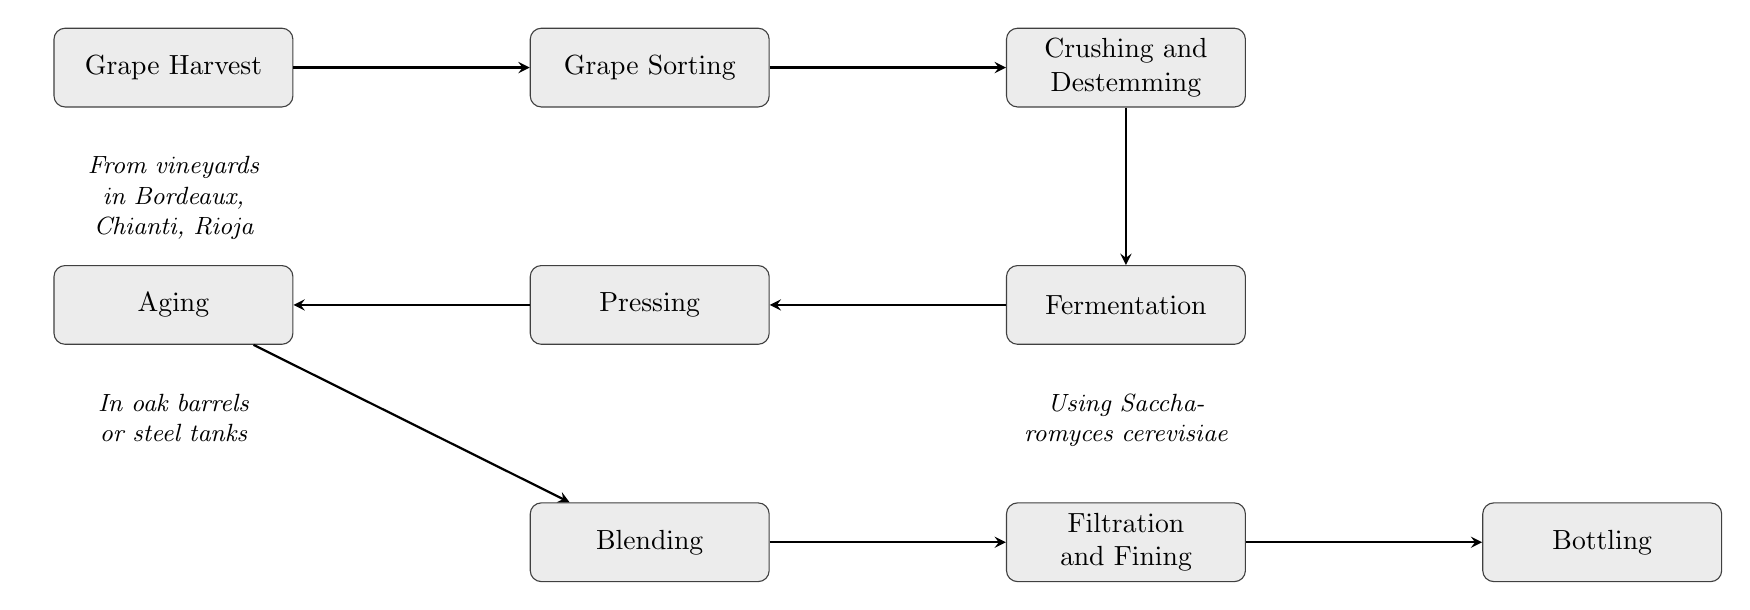What is the first step in the journey of red wine? The first node in the diagram is "Grape Harvest", indicating that the process begins with this step.
Answer: Grape Harvest How many nodes are in the diagram? By counting the distinct processes listed in the diagram, there are a total of nine nodes.
Answer: 9 What follows after Grape Sorting? The diagram shows an arrow leading from "Grape Sorting" to "Crushing and Destemming", indicating that this is the next step in the process.
Answer: Crushing and Destemming Which process involves aging in barrels? The node labeled "Aging" describes the process of aging wine in oak barrels or stainless-steel tanks.
Answer: Aging What is used during the fermentation process? The annotation under the "Fermentation" node indicates that Saccharomyces cerevisiae is commonly used as yeast during this stage.
Answer: Saccharomyces cerevisiae What is the relationship between Pressing and Pressing? The diagram shows that after "Fermentation", the flow goes to "Pressing", indicating a sequential relationship where pressing occurs after fermentation.
Answer: Sequential relationship Which step immediately precedes Bottling? According to the flow chart, the step "Filtration and Fining" comes right before "Bottling".
Answer: Filtration and Fining In which vineyards is grape harvesting commonly done? The note under the "Grape Harvest" node states that these vineyards include Bordeaux, Chianti, and Rioja, indicating common locations for harvest.
Answer: Bordeaux, Chianti, Rioja 